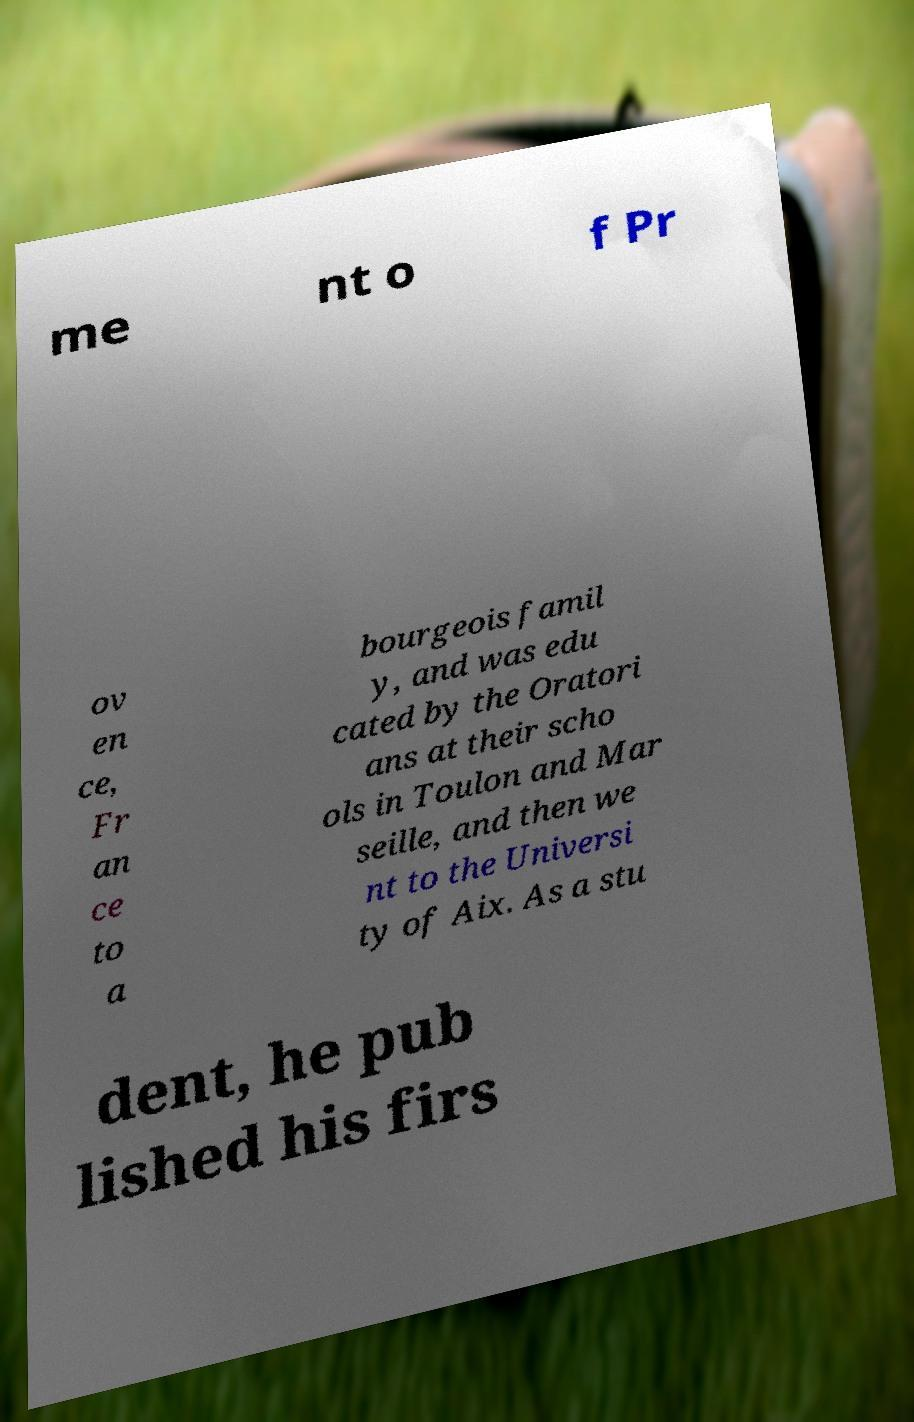I need the written content from this picture converted into text. Can you do that? me nt o f Pr ov en ce, Fr an ce to a bourgeois famil y, and was edu cated by the Oratori ans at their scho ols in Toulon and Mar seille, and then we nt to the Universi ty of Aix. As a stu dent, he pub lished his firs 